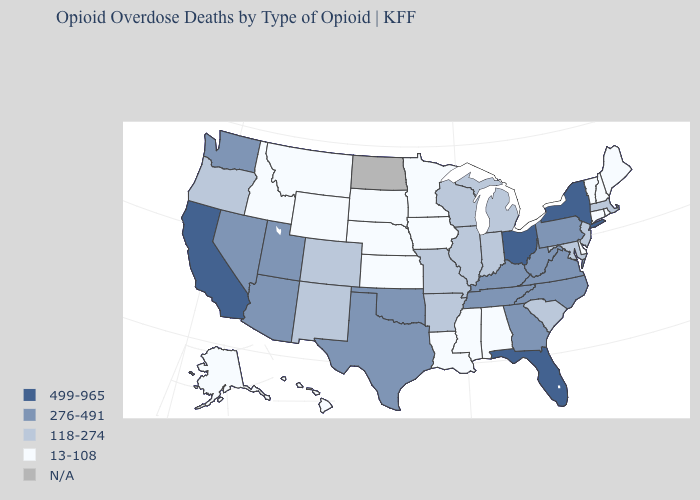Name the states that have a value in the range 13-108?
Give a very brief answer. Alabama, Alaska, Connecticut, Delaware, Hawaii, Idaho, Iowa, Kansas, Louisiana, Maine, Minnesota, Mississippi, Montana, Nebraska, New Hampshire, Rhode Island, South Dakota, Vermont, Wyoming. Does South Dakota have the lowest value in the MidWest?
Write a very short answer. Yes. Which states have the highest value in the USA?
Give a very brief answer. California, Florida, New York, Ohio. What is the value of Oregon?
Concise answer only. 118-274. What is the highest value in the West ?
Keep it brief. 499-965. Name the states that have a value in the range 499-965?
Quick response, please. California, Florida, New York, Ohio. Which states have the lowest value in the USA?
Give a very brief answer. Alabama, Alaska, Connecticut, Delaware, Hawaii, Idaho, Iowa, Kansas, Louisiana, Maine, Minnesota, Mississippi, Montana, Nebraska, New Hampshire, Rhode Island, South Dakota, Vermont, Wyoming. What is the value of Massachusetts?
Short answer required. 118-274. What is the lowest value in states that border Connecticut?
Quick response, please. 13-108. What is the value of Wisconsin?
Write a very short answer. 118-274. What is the value of Washington?
Be succinct. 276-491. Does the map have missing data?
Keep it brief. Yes. What is the highest value in the Northeast ?
Write a very short answer. 499-965. What is the highest value in states that border Iowa?
Be succinct. 118-274. 